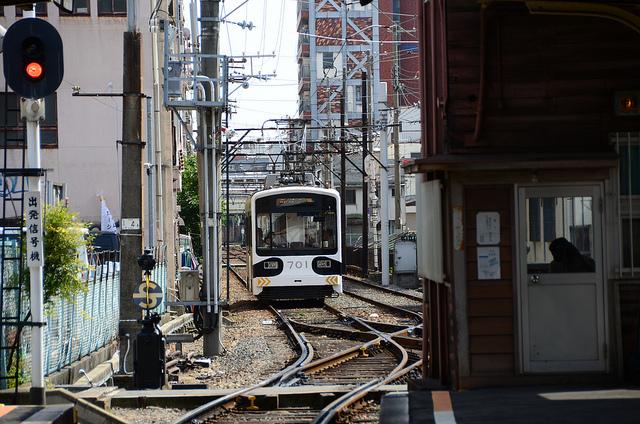Is this a city street?
Concise answer only. No. Is there a bush next to the fence?
Short answer required. Yes. Where are the train cars housed?
Short answer required. Tracks. Are there any lights on the train?
Keep it brief. No. Is there a ticket counter?
Keep it brief. Yes. Is this a train station?
Keep it brief. Yes. What color is the train?
Give a very brief answer. White. How many street lights are there?
Give a very brief answer. 1. Can you cash your paycheck nearby?
Quick response, please. No. Is this a safe city?
Short answer required. No. 